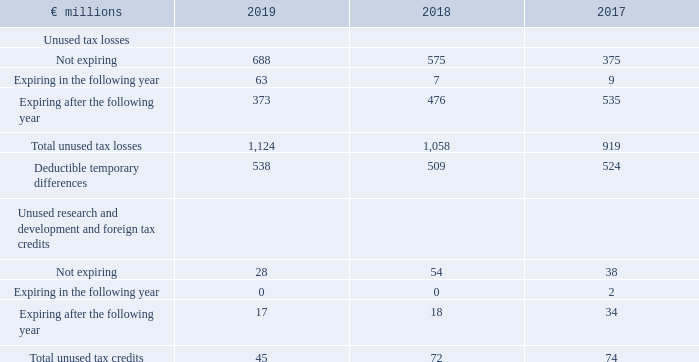Items Not Resulting in a Deferred Tax Asset
Of the unused tax losses, €187 million (2018: €213 million; 2017: €263 million) relate to U.S. state tax loss carryforwards.
We have not recognized a deferred tax liability on approximately €17.41 billion (2018: €14.04 billion) for undistributed profits of our subsidiaries, because we are in a position to control the timing of the reversal of the temporary difference and it is probable that such differences will not reverse in the foreseeable future.
How much of unused tax losses relate to U.S. state tax loss carryforwards in 2019? €187 million. What was the Total unused tax credits in 2019?
Answer scale should be: million. 45. In which years were the total unused tax losses calculated? 2019, 2018, 2017. In which year was the amount Expiring after the following year the largest? 34>18>17
Answer: 2017. What was the change in the amount Expiring after the following year in 2019 from 2018?
Answer scale should be: million. 17-18
Answer: -1. What was the percentage change in the amount Expiring after the following year in 2019 from 2018?
Answer scale should be: percent. (17-18)/18
Answer: -5.56. 